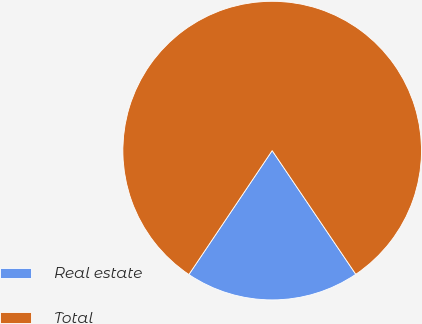Convert chart to OTSL. <chart><loc_0><loc_0><loc_500><loc_500><pie_chart><fcel>Real estate<fcel>Total<nl><fcel>18.88%<fcel>81.12%<nl></chart> 